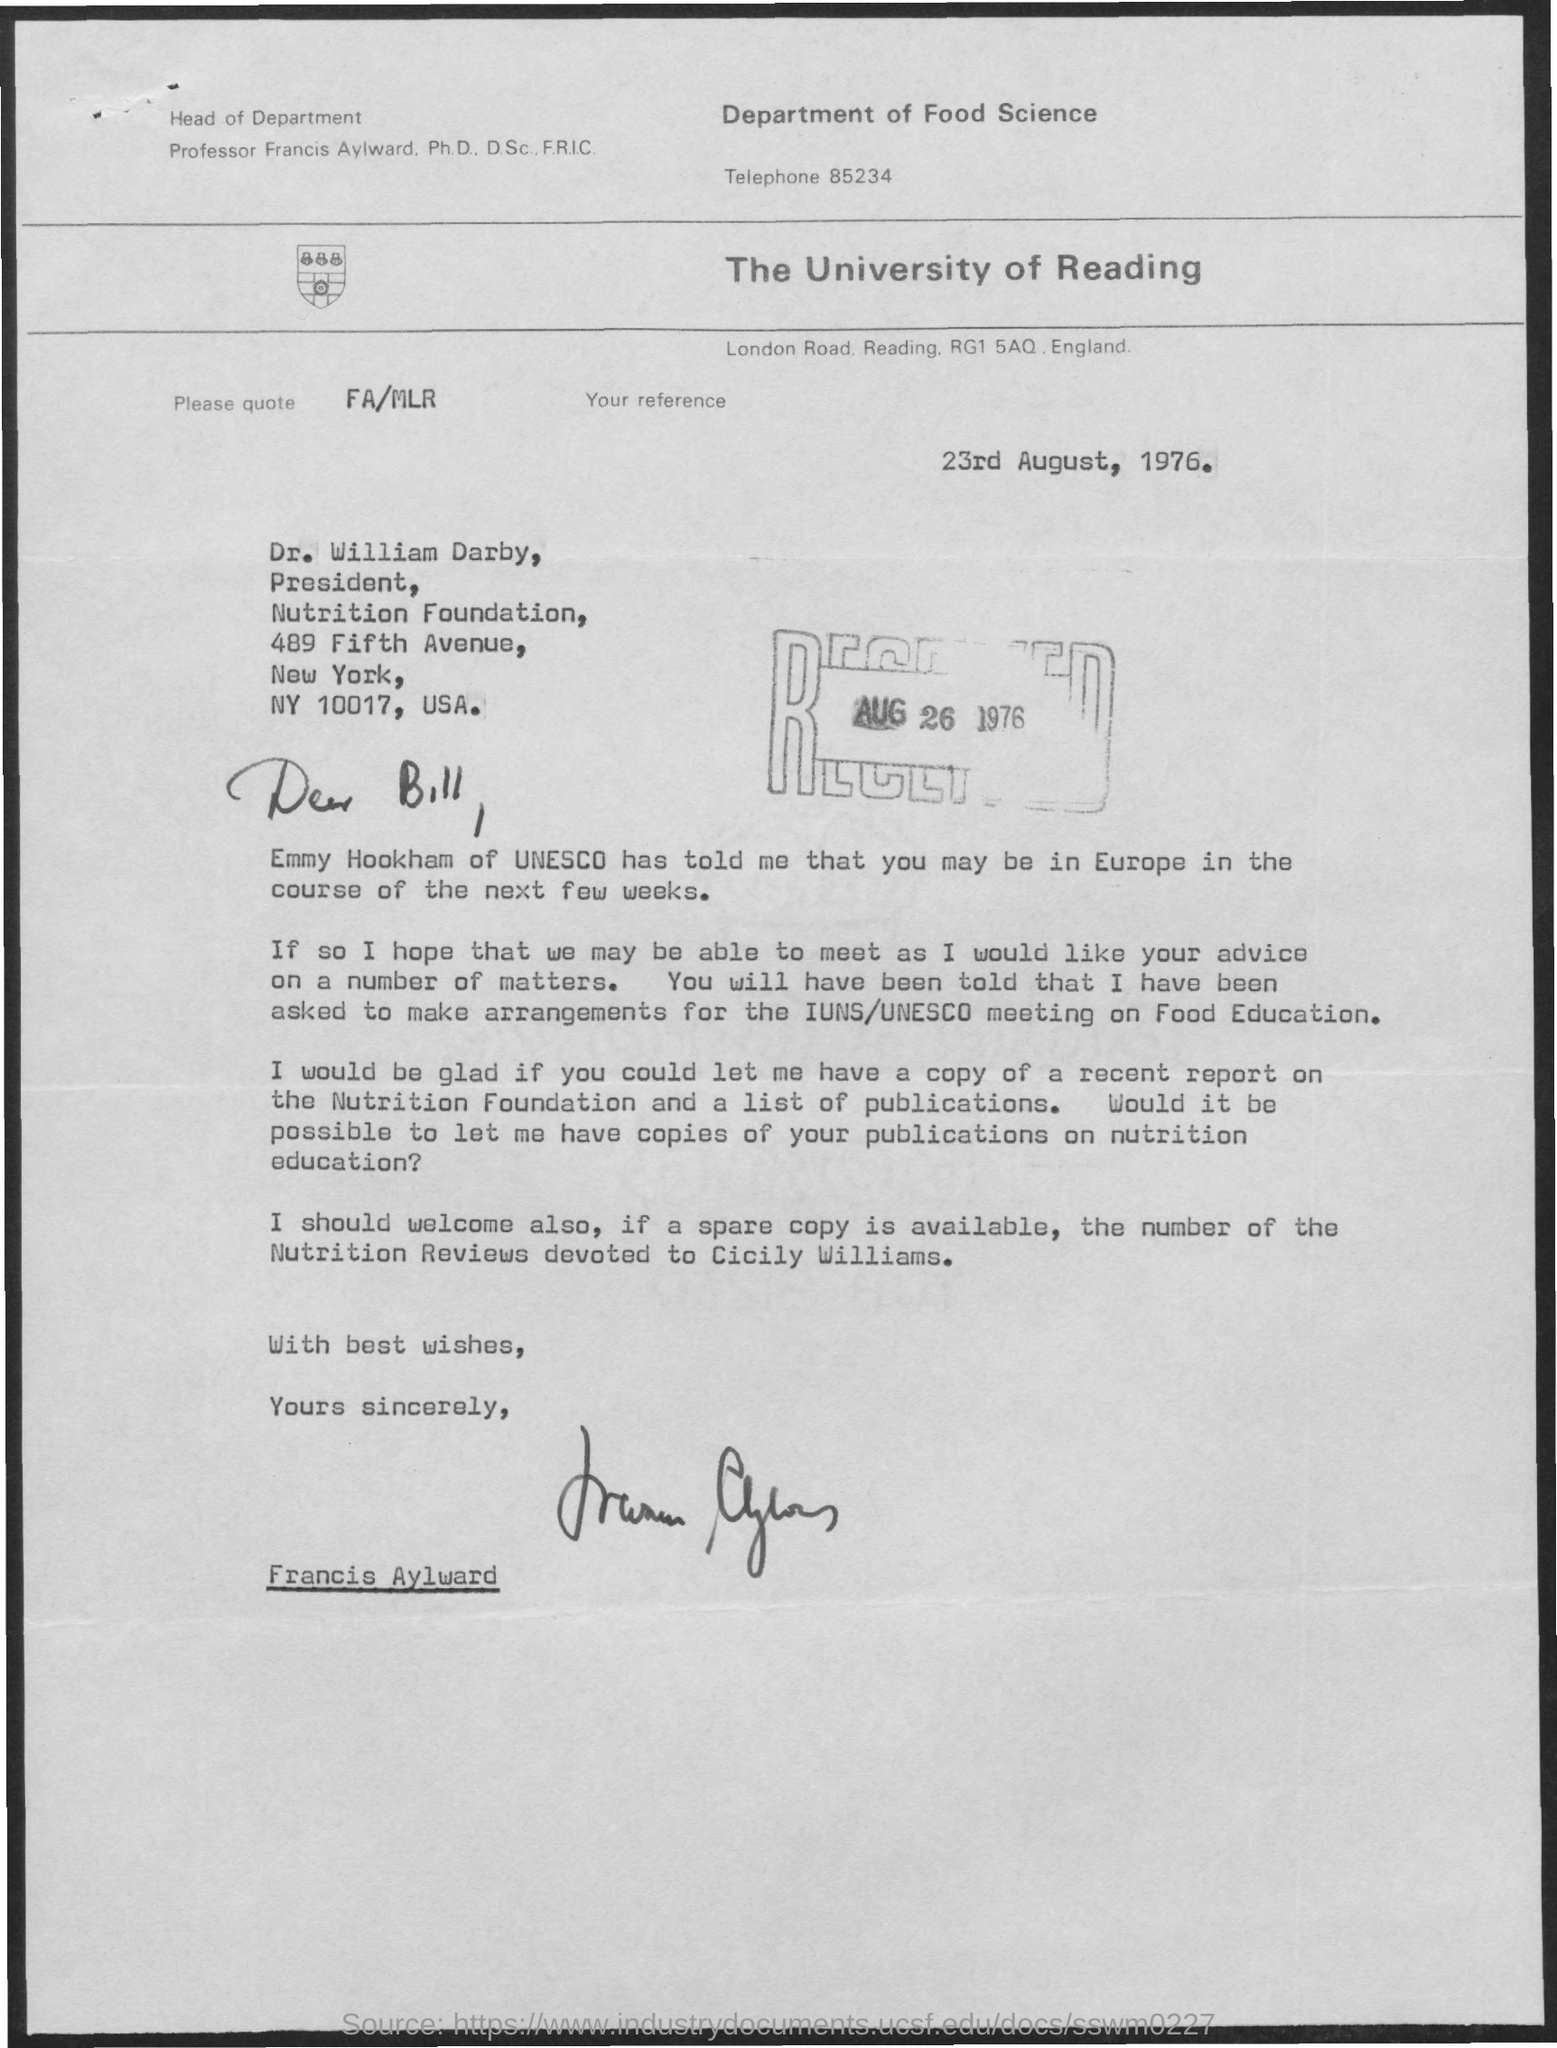Highlight a few significant elements in this photo. Francis Aylward is the head of the department. Francis Aylward is the person who wrote the letter. The document mentions the Department of Food Science. 